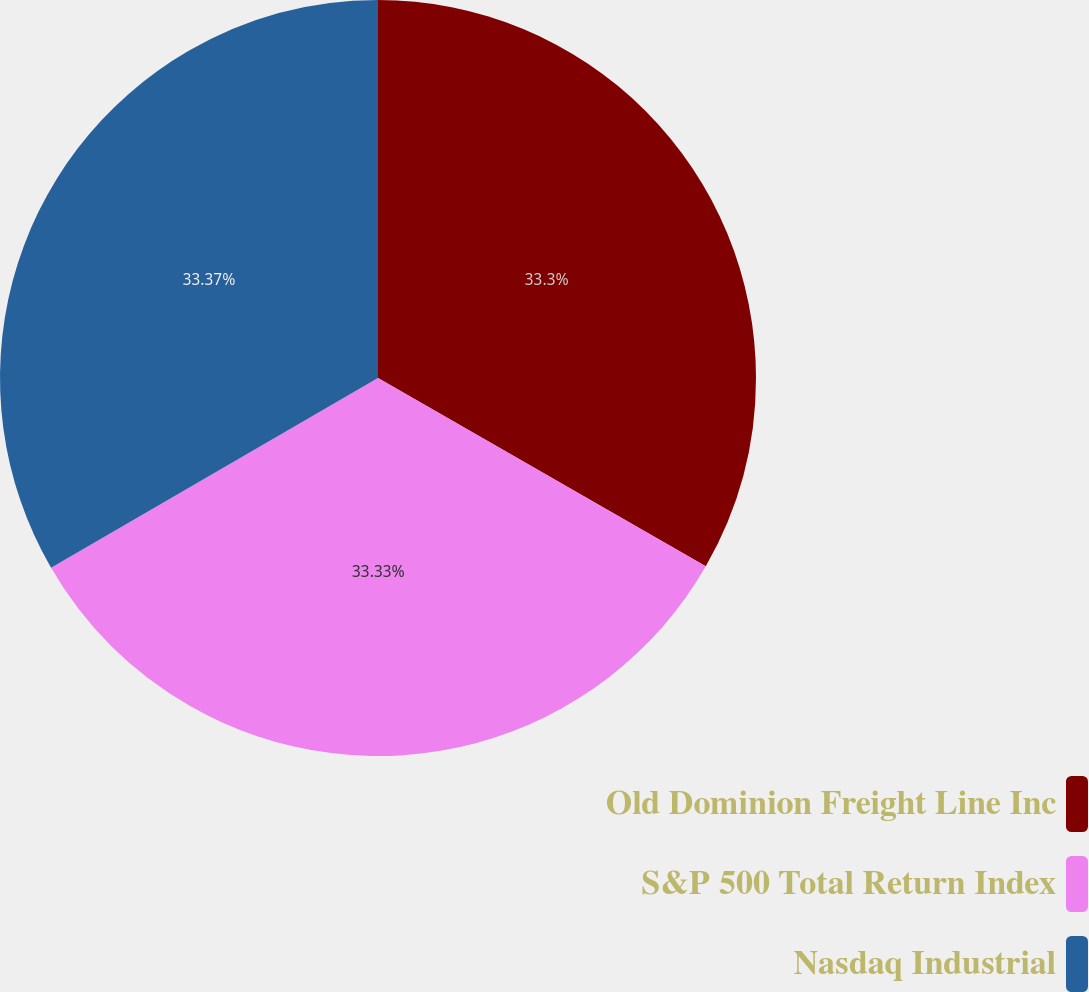Convert chart to OTSL. <chart><loc_0><loc_0><loc_500><loc_500><pie_chart><fcel>Old Dominion Freight Line Inc<fcel>S&P 500 Total Return Index<fcel>Nasdaq Industrial<nl><fcel>33.3%<fcel>33.33%<fcel>33.37%<nl></chart> 